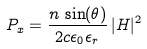<formula> <loc_0><loc_0><loc_500><loc_500>P _ { x } = \frac { n \, \sin ( \theta ) } { 2 c \epsilon _ { 0 } \epsilon _ { r } } \, | H | ^ { 2 }</formula> 